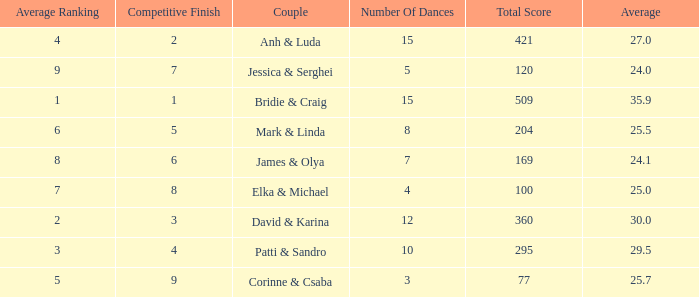What is the average for the couple anh & luda? 27.0. 